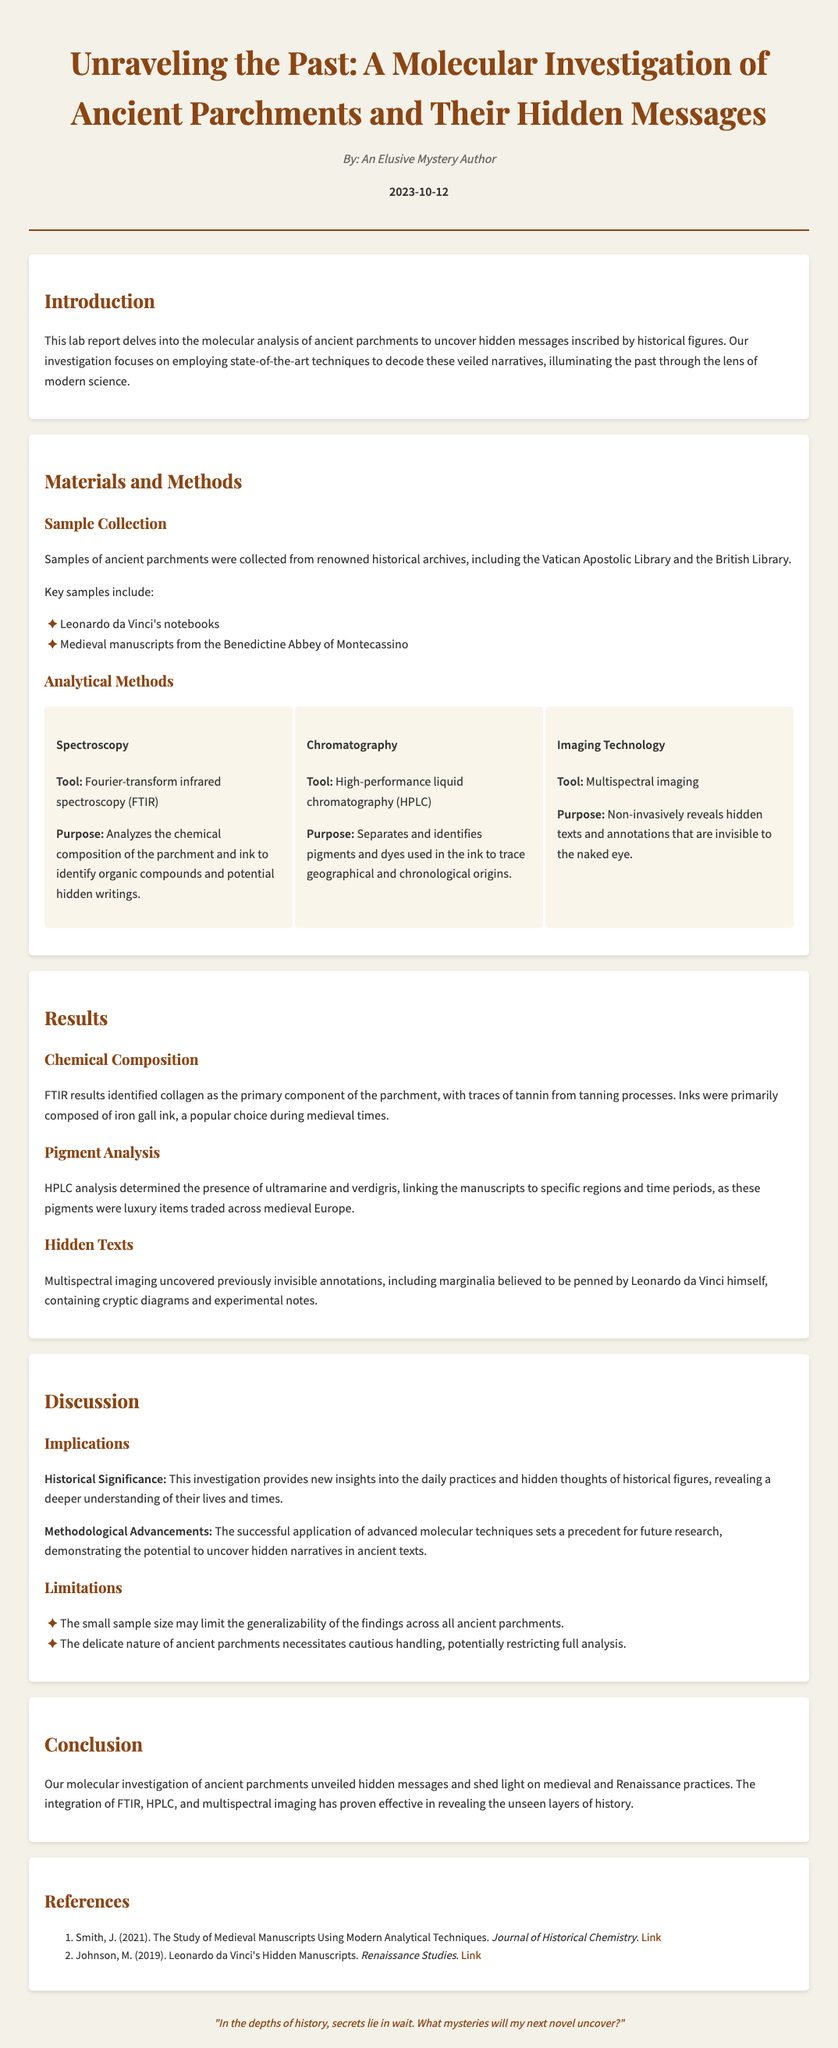What is the title of the lab report? The title is the main heading of the document that summarizes its focus on ancient parchments.
Answer: Unraveling the Past: A Molecular Investigation of Ancient Parchments and Their Hidden Messages Who is the author of the report? The author is mentioned in the header section of the document.
Answer: An Elusive Mystery Author What is the date of publication? The publication date is noted in the header beneath the author's name.
Answer: 2023-10-12 What molecular technique was used to analyze chemical composition? This technique is specifically listed under the Analytical Methods section.
Answer: Fourier-transform infrared spectroscopy (FTIR) What pigments were identified in the HPLC analysis? The mentioned pigments highlight their historical significance in the documents.
Answer: Ultramarine and verdigris What primary component was found in the parchment? This information summarizes the results of the FTIR analysis on the parchment samples.
Answer: Collagen What historical figure is associated with the marginalia discovered? The report indicates a notable figure linked to the hidden texts.
Answer: Leonardo da Vinci What is one limitation of the study mentioned in the discussion? The limitations explain factors that may affect the study's findings.
Answer: Small sample size What technology revealed hidden texts and annotations? This tool is described in the Analytical Methods section, focusing on non-invasive techniques.
Answer: Multispectral imaging 